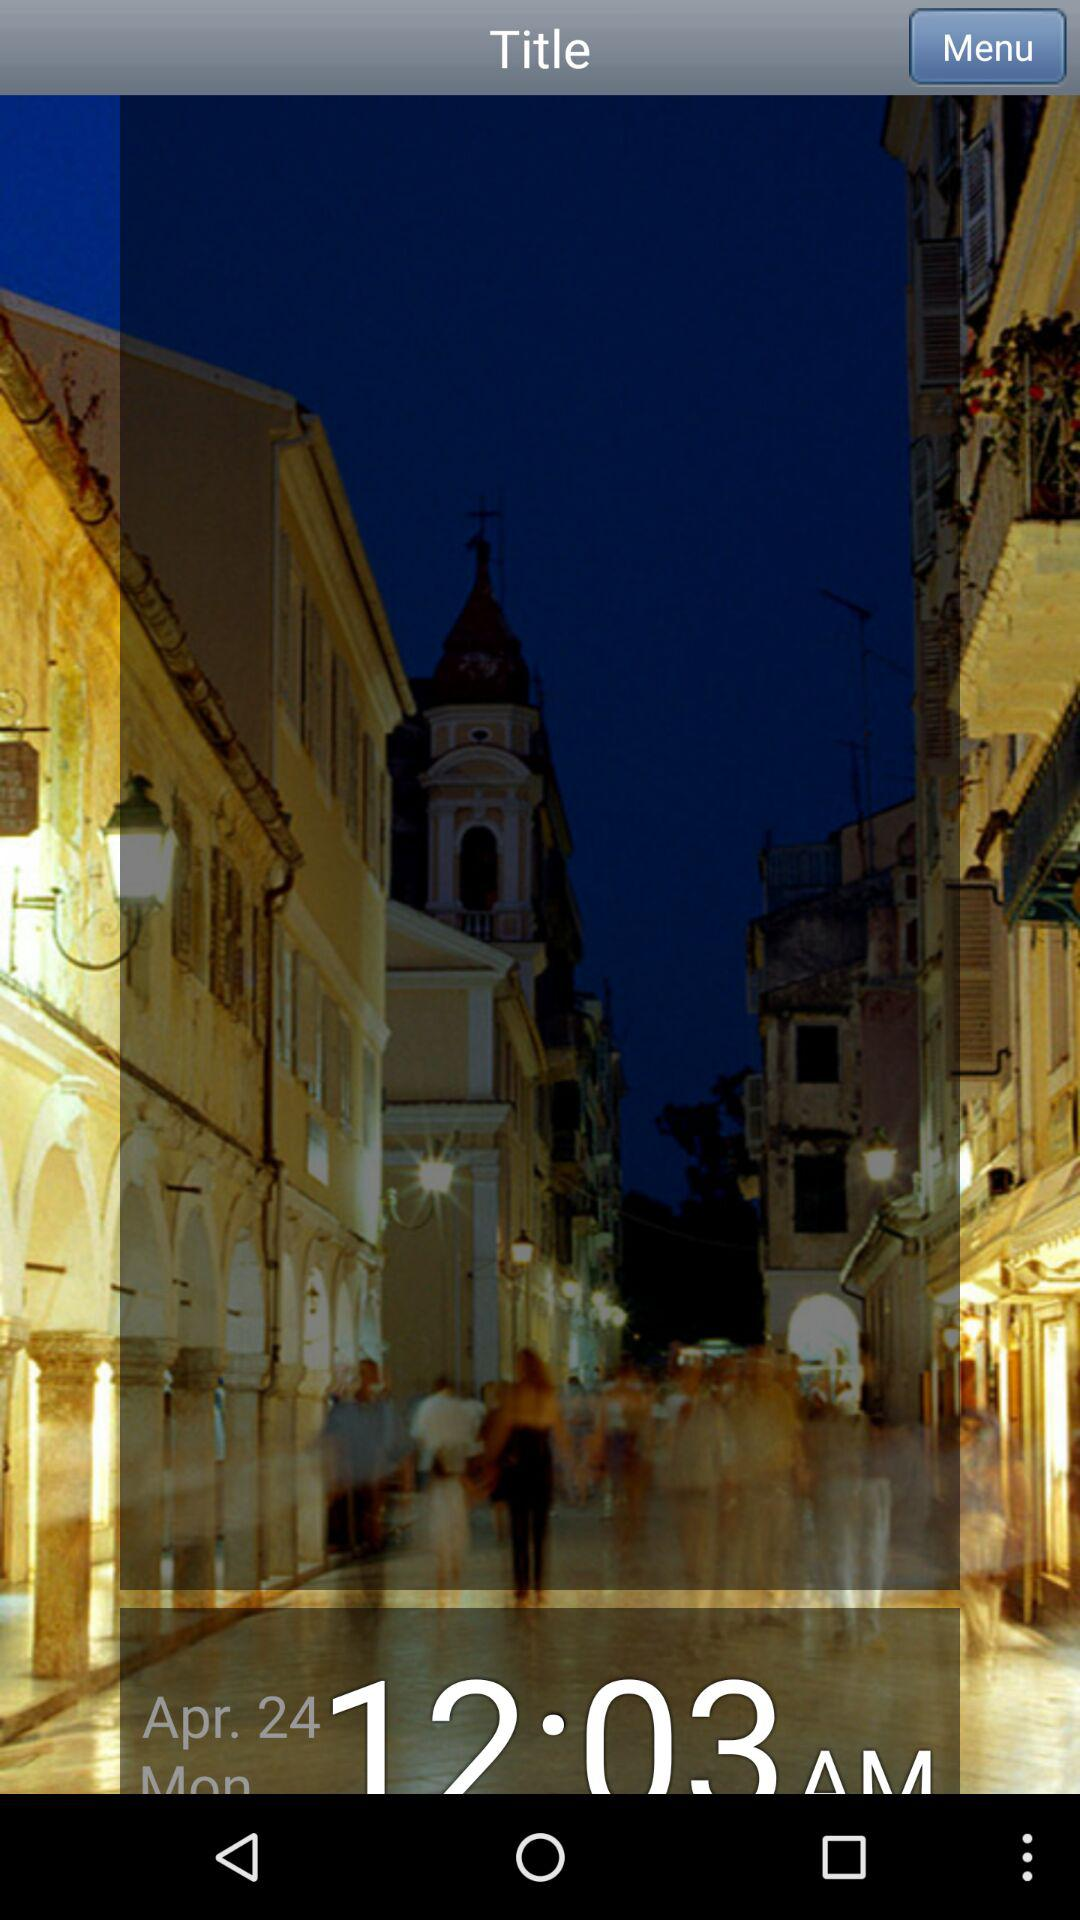What is the given date and time? The given date and time are April 24 and 12:03 a.m., respectively. 